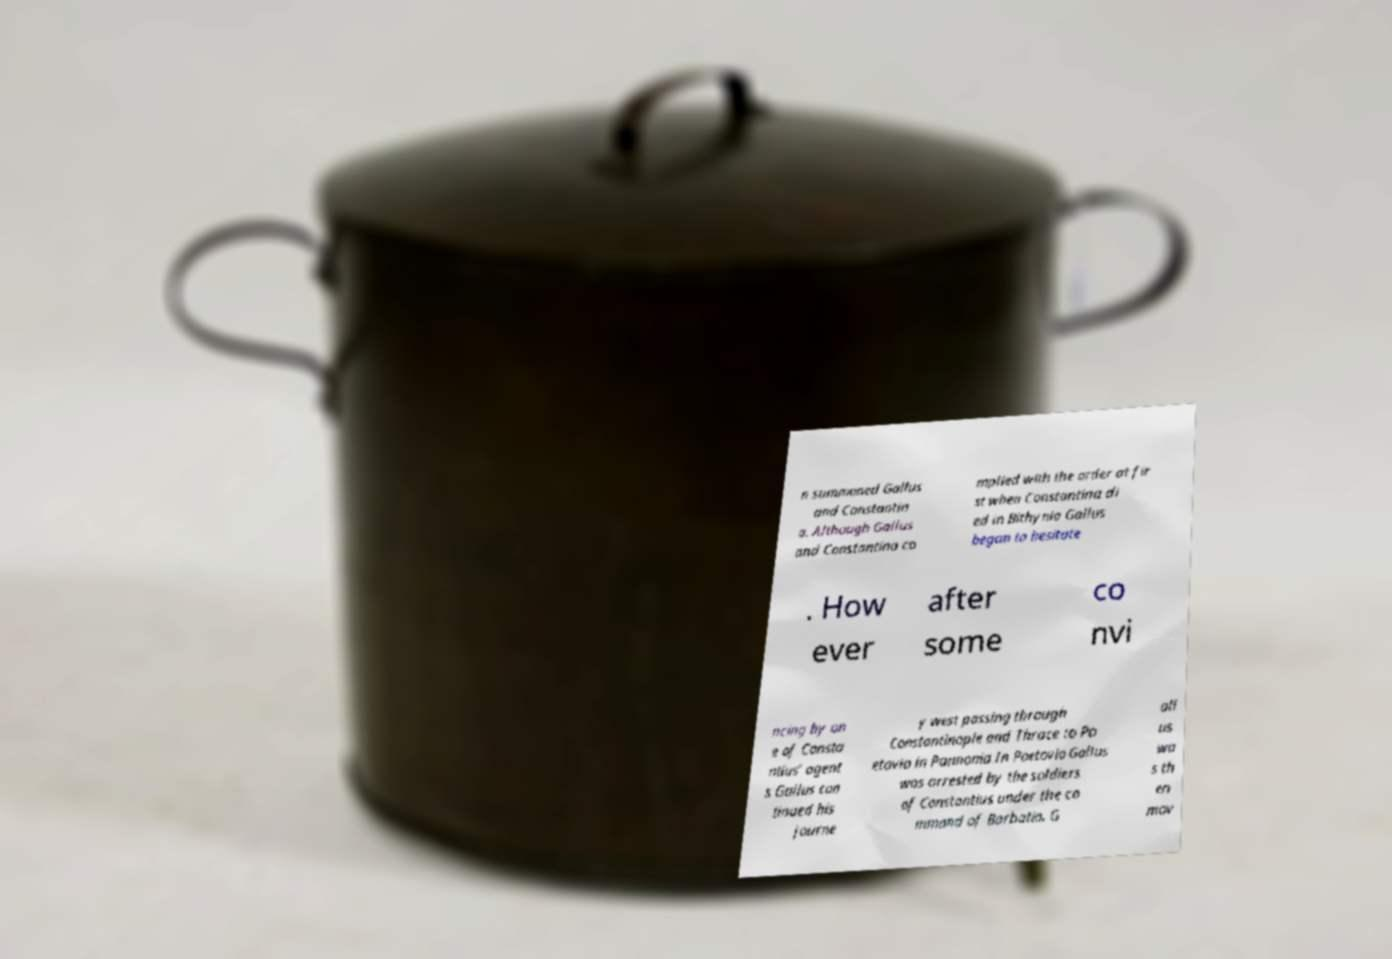What messages or text are displayed in this image? I need them in a readable, typed format. n summoned Gallus and Constantin a. Although Gallus and Constantina co mplied with the order at fir st when Constantina di ed in Bithynia Gallus began to hesitate . How ever after some co nvi ncing by on e of Consta ntius’ agent s Gallus con tinued his journe y west passing through Constantinople and Thrace to Po etovio in Pannonia.In Poetovio Gallus was arrested by the soldiers of Constantius under the co mmand of Barbatio. G all us wa s th en mov 